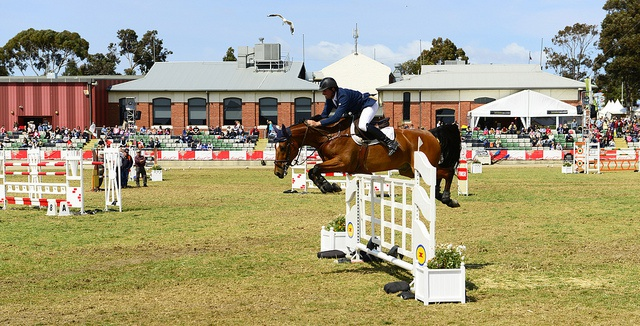Describe the objects in this image and their specific colors. I can see people in lightblue, black, lightgray, gray, and darkgray tones, horse in lightblue, black, maroon, and brown tones, people in lightblue, black, navy, white, and gray tones, people in lightblue, black, maroon, and gray tones, and people in lightblue, black, maroon, navy, and gray tones in this image. 